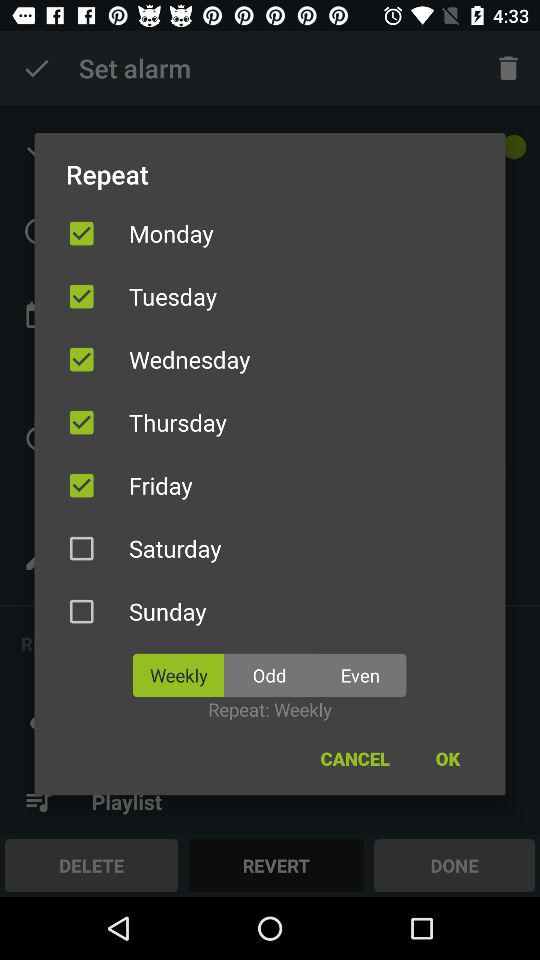Which alternative is selected to repeat the alarm? The selected alternative to repeat the alarm is "Weekly". 